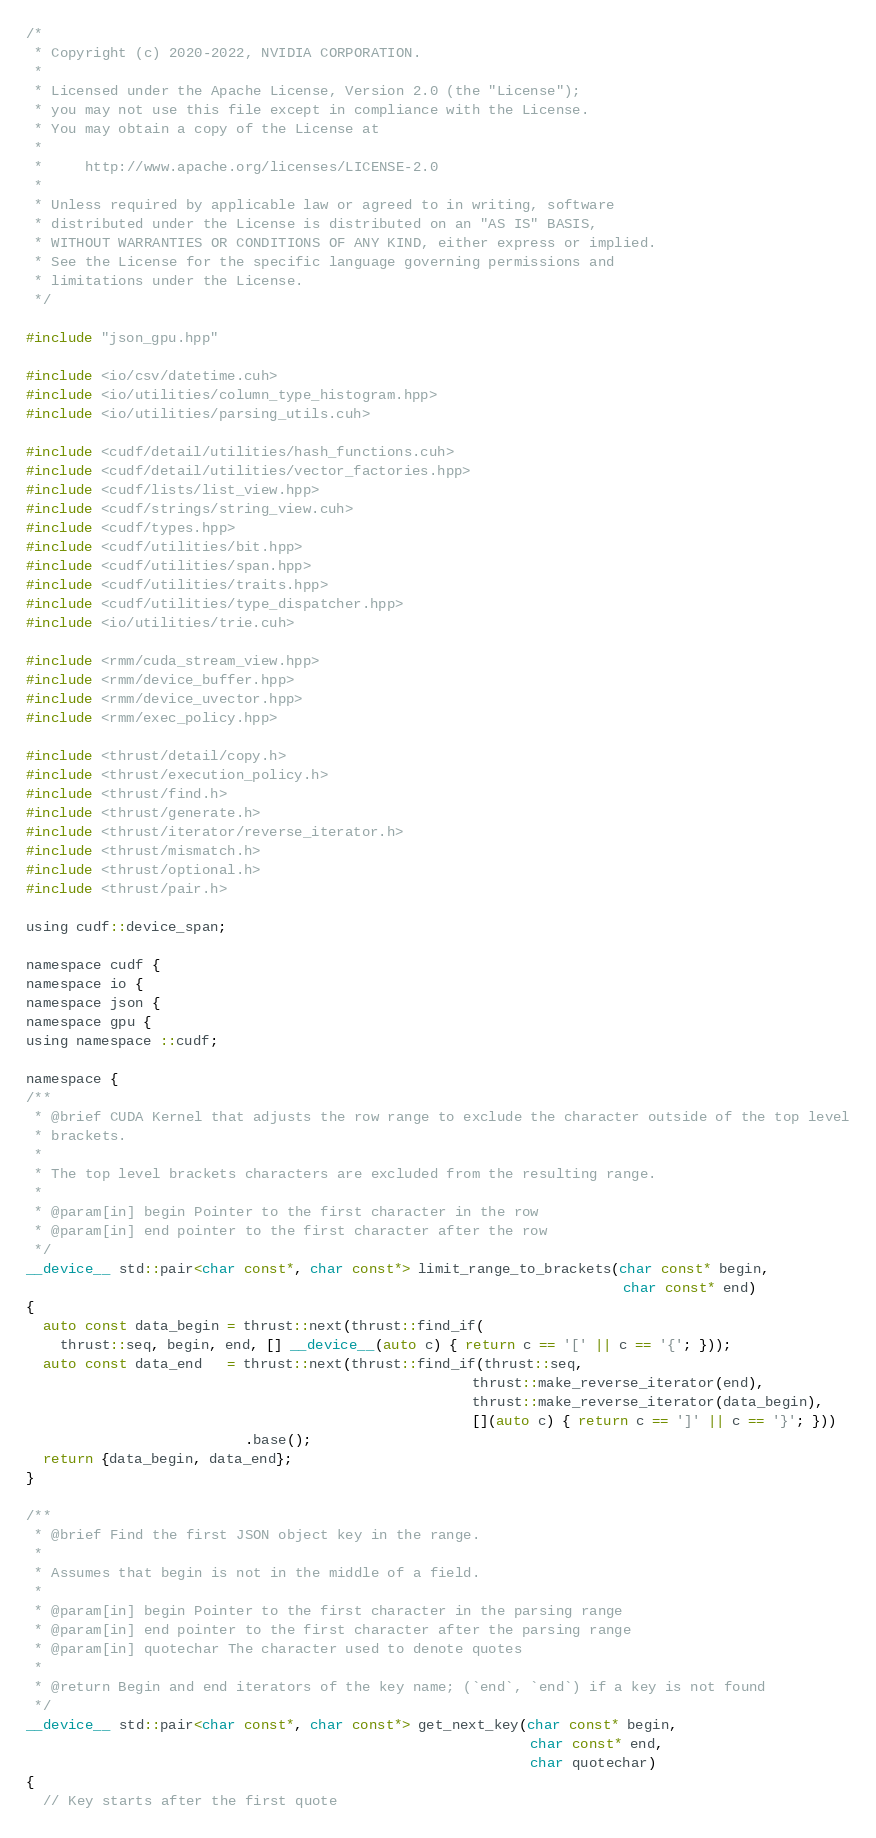<code> <loc_0><loc_0><loc_500><loc_500><_Cuda_>/*
 * Copyright (c) 2020-2022, NVIDIA CORPORATION.
 *
 * Licensed under the Apache License, Version 2.0 (the "License");
 * you may not use this file except in compliance with the License.
 * You may obtain a copy of the License at
 *
 *     http://www.apache.org/licenses/LICENSE-2.0
 *
 * Unless required by applicable law or agreed to in writing, software
 * distributed under the License is distributed on an "AS IS" BASIS,
 * WITHOUT WARRANTIES OR CONDITIONS OF ANY KIND, either express or implied.
 * See the License for the specific language governing permissions and
 * limitations under the License.
 */

#include "json_gpu.hpp"

#include <io/csv/datetime.cuh>
#include <io/utilities/column_type_histogram.hpp>
#include <io/utilities/parsing_utils.cuh>

#include <cudf/detail/utilities/hash_functions.cuh>
#include <cudf/detail/utilities/vector_factories.hpp>
#include <cudf/lists/list_view.hpp>
#include <cudf/strings/string_view.cuh>
#include <cudf/types.hpp>
#include <cudf/utilities/bit.hpp>
#include <cudf/utilities/span.hpp>
#include <cudf/utilities/traits.hpp>
#include <cudf/utilities/type_dispatcher.hpp>
#include <io/utilities/trie.cuh>

#include <rmm/cuda_stream_view.hpp>
#include <rmm/device_buffer.hpp>
#include <rmm/device_uvector.hpp>
#include <rmm/exec_policy.hpp>

#include <thrust/detail/copy.h>
#include <thrust/execution_policy.h>
#include <thrust/find.h>
#include <thrust/generate.h>
#include <thrust/iterator/reverse_iterator.h>
#include <thrust/mismatch.h>
#include <thrust/optional.h>
#include <thrust/pair.h>

using cudf::device_span;

namespace cudf {
namespace io {
namespace json {
namespace gpu {
using namespace ::cudf;

namespace {
/**
 * @brief CUDA Kernel that adjusts the row range to exclude the character outside of the top level
 * brackets.
 *
 * The top level brackets characters are excluded from the resulting range.
 *
 * @param[in] begin Pointer to the first character in the row
 * @param[in] end pointer to the first character after the row
 */
__device__ std::pair<char const*, char const*> limit_range_to_brackets(char const* begin,
                                                                       char const* end)
{
  auto const data_begin = thrust::next(thrust::find_if(
    thrust::seq, begin, end, [] __device__(auto c) { return c == '[' || c == '{'; }));
  auto const data_end   = thrust::next(thrust::find_if(thrust::seq,
                                                     thrust::make_reverse_iterator(end),
                                                     thrust::make_reverse_iterator(data_begin),
                                                     [](auto c) { return c == ']' || c == '}'; }))
                          .base();
  return {data_begin, data_end};
}

/**
 * @brief Find the first JSON object key in the range.
 *
 * Assumes that begin is not in the middle of a field.
 *
 * @param[in] begin Pointer to the first character in the parsing range
 * @param[in] end pointer to the first character after the parsing range
 * @param[in] quotechar The character used to denote quotes
 *
 * @return Begin and end iterators of the key name; (`end`, `end`) if a key is not found
 */
__device__ std::pair<char const*, char const*> get_next_key(char const* begin,
                                                            char const* end,
                                                            char quotechar)
{
  // Key starts after the first quote</code> 